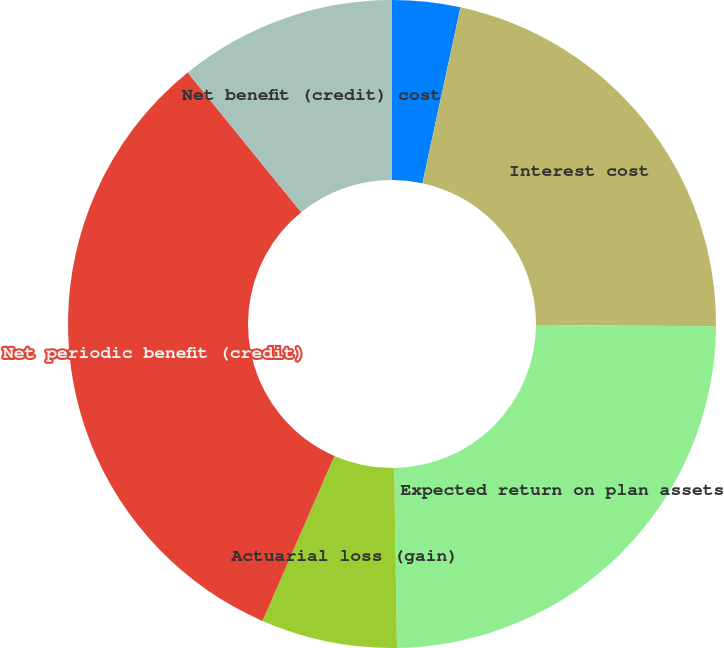Convert chart. <chart><loc_0><loc_0><loc_500><loc_500><pie_chart><fcel>Service cost<fcel>Interest cost<fcel>Expected return on plan assets<fcel>Actuarial loss (gain)<fcel>Net periodic benefit (credit)<fcel>Net benefit (credit) cost<nl><fcel>3.39%<fcel>21.72%<fcel>24.64%<fcel>6.79%<fcel>32.59%<fcel>10.86%<nl></chart> 